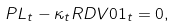Convert formula to latex. <formula><loc_0><loc_0><loc_500><loc_500>P L _ { t } - \kappa _ { t } R D V 0 1 _ { t } = 0 ,</formula> 